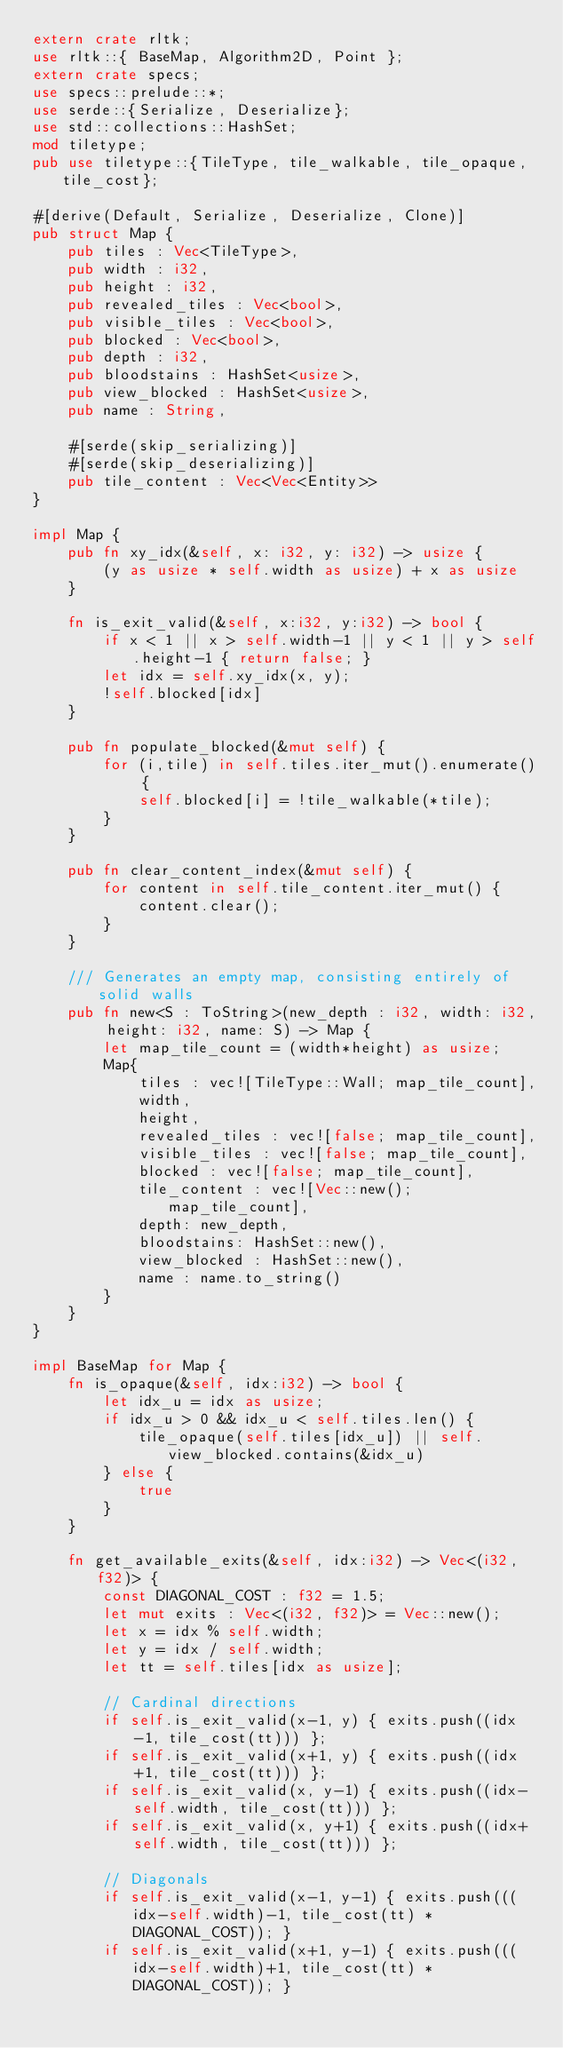Convert code to text. <code><loc_0><loc_0><loc_500><loc_500><_Rust_>extern crate rltk;
use rltk::{ BaseMap, Algorithm2D, Point };
extern crate specs;
use specs::prelude::*;
use serde::{Serialize, Deserialize};
use std::collections::HashSet;
mod tiletype;
pub use tiletype::{TileType, tile_walkable, tile_opaque, tile_cost};

#[derive(Default, Serialize, Deserialize, Clone)]
pub struct Map {
    pub tiles : Vec<TileType>,
    pub width : i32,
    pub height : i32,
    pub revealed_tiles : Vec<bool>,
    pub visible_tiles : Vec<bool>,
    pub blocked : Vec<bool>,
    pub depth : i32,
    pub bloodstains : HashSet<usize>,
    pub view_blocked : HashSet<usize>,
    pub name : String,

    #[serde(skip_serializing)]
    #[serde(skip_deserializing)]
    pub tile_content : Vec<Vec<Entity>>
}

impl Map {
    pub fn xy_idx(&self, x: i32, y: i32) -> usize {
        (y as usize * self.width as usize) + x as usize
    }

    fn is_exit_valid(&self, x:i32, y:i32) -> bool {
        if x < 1 || x > self.width-1 || y < 1 || y > self.height-1 { return false; }
        let idx = self.xy_idx(x, y);
        !self.blocked[idx]
    }

    pub fn populate_blocked(&mut self) {
        for (i,tile) in self.tiles.iter_mut().enumerate() {
            self.blocked[i] = !tile_walkable(*tile);
        }
    }

    pub fn clear_content_index(&mut self) {
        for content in self.tile_content.iter_mut() {
            content.clear();
        }
    }

    /// Generates an empty map, consisting entirely of solid walls
    pub fn new<S : ToString>(new_depth : i32, width: i32, height: i32, name: S) -> Map {
        let map_tile_count = (width*height) as usize;
        Map{
            tiles : vec![TileType::Wall; map_tile_count],
            width,
            height,
            revealed_tiles : vec![false; map_tile_count],
            visible_tiles : vec![false; map_tile_count],
            blocked : vec![false; map_tile_count],
            tile_content : vec![Vec::new(); map_tile_count],
            depth: new_depth,
            bloodstains: HashSet::new(),
            view_blocked : HashSet::new(),
            name : name.to_string()
        }
    }
}

impl BaseMap for Map {
    fn is_opaque(&self, idx:i32) -> bool {
        let idx_u = idx as usize;
        if idx_u > 0 && idx_u < self.tiles.len() {
            tile_opaque(self.tiles[idx_u]) || self.view_blocked.contains(&idx_u)
        } else {
            true
        }
    }

    fn get_available_exits(&self, idx:i32) -> Vec<(i32, f32)> {
        const DIAGONAL_COST : f32 = 1.5;
        let mut exits : Vec<(i32, f32)> = Vec::new();
        let x = idx % self.width;
        let y = idx / self.width;
        let tt = self.tiles[idx as usize];

        // Cardinal directions
        if self.is_exit_valid(x-1, y) { exits.push((idx-1, tile_cost(tt))) };
        if self.is_exit_valid(x+1, y) { exits.push((idx+1, tile_cost(tt))) };
        if self.is_exit_valid(x, y-1) { exits.push((idx-self.width, tile_cost(tt))) };
        if self.is_exit_valid(x, y+1) { exits.push((idx+self.width, tile_cost(tt))) };

        // Diagonals
        if self.is_exit_valid(x-1, y-1) { exits.push(((idx-self.width)-1, tile_cost(tt) * DIAGONAL_COST)); }
        if self.is_exit_valid(x+1, y-1) { exits.push(((idx-self.width)+1, tile_cost(tt) * DIAGONAL_COST)); }</code> 